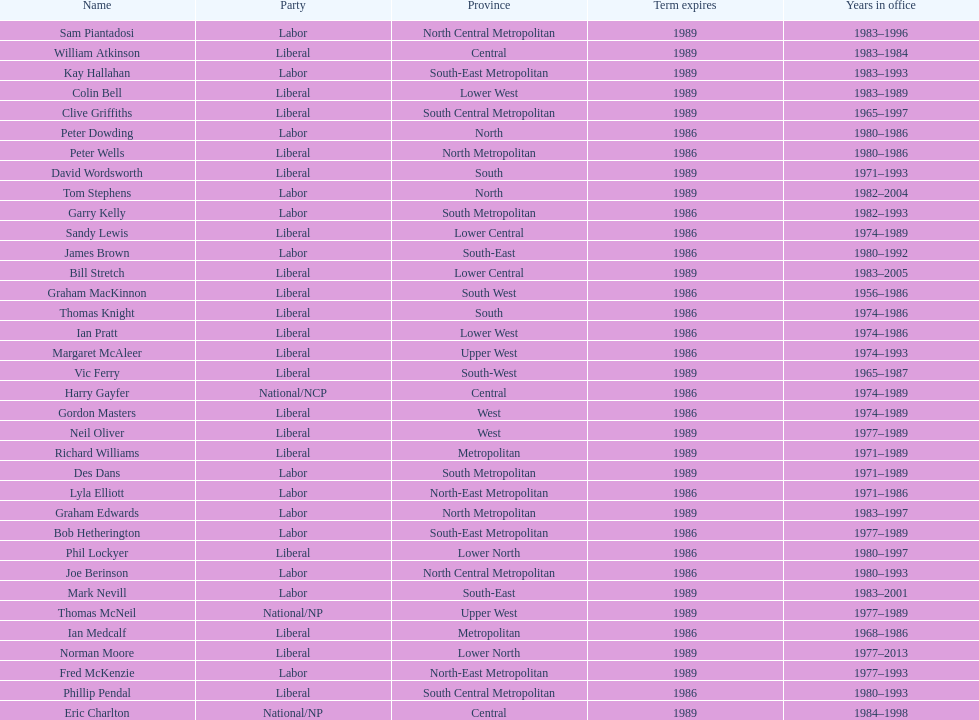What was phil lockyer's party? Liberal. 